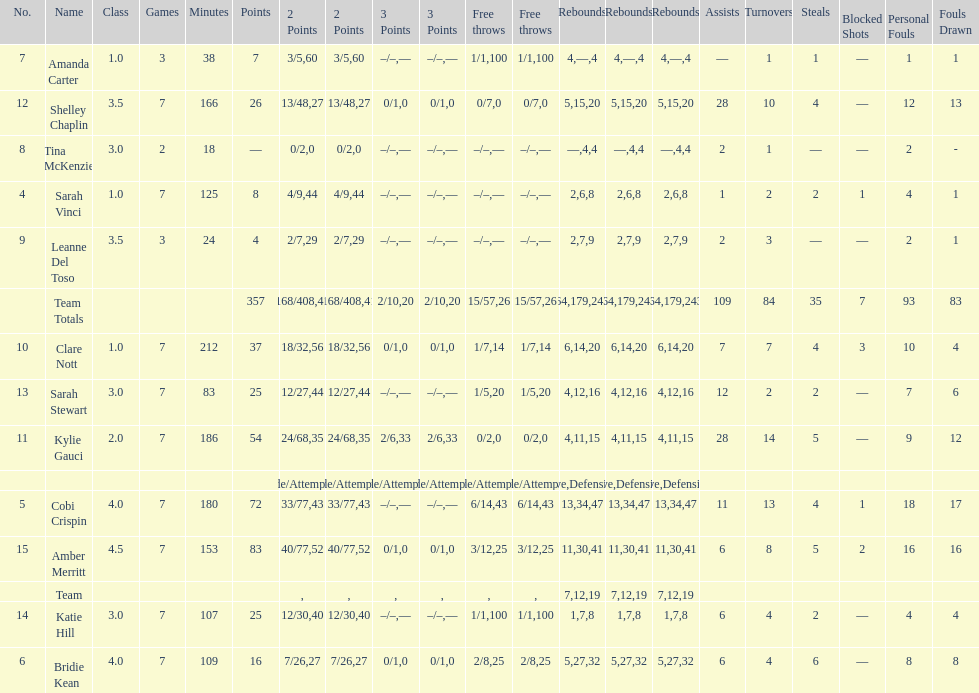Who is the last player on the list to not attempt a 3 point shot? Katie Hill. 